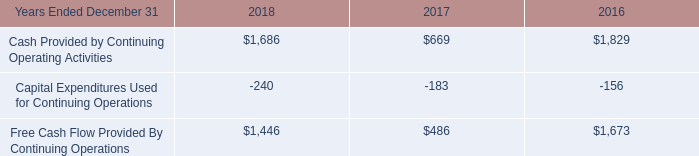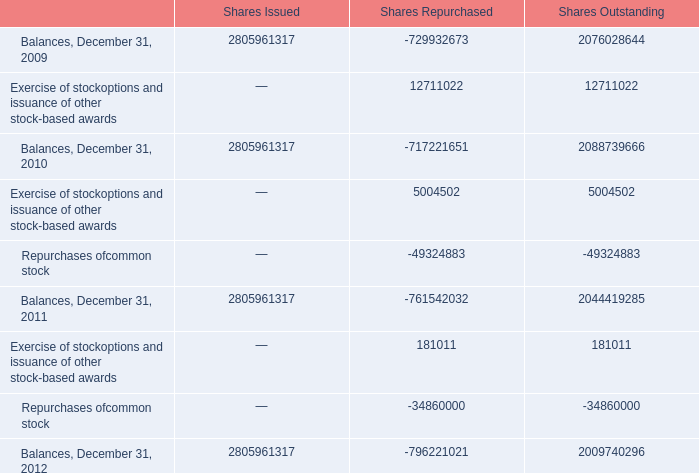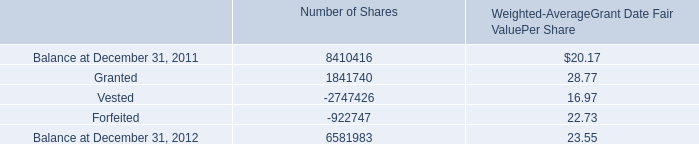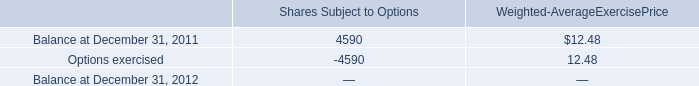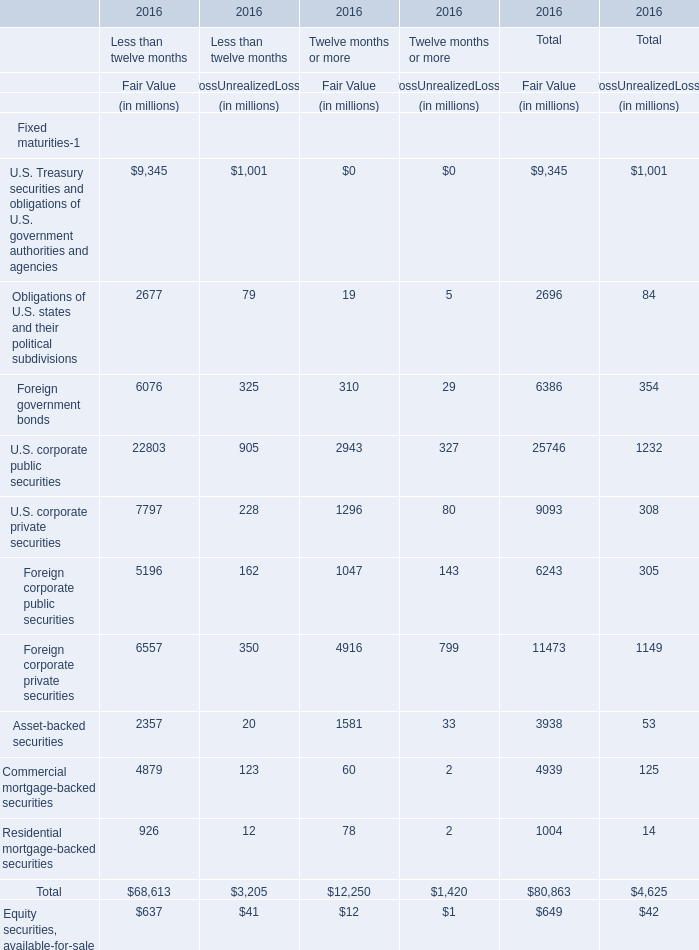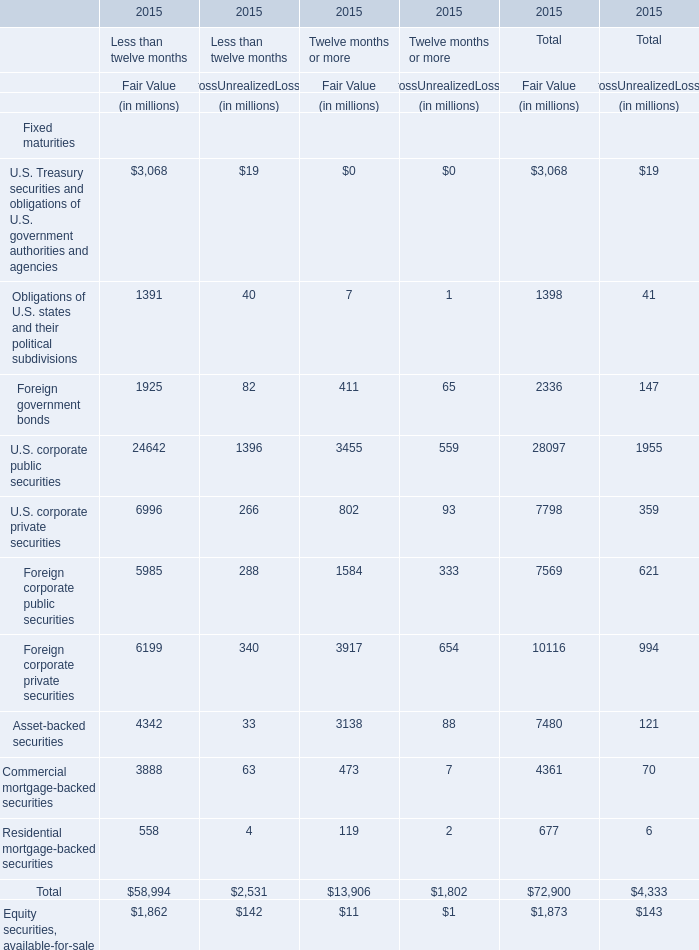What is the average amount of Free Cash Flow Provided By Continuing Operations of 2016, and Balance at December 31, 2011 of Shares Subject to Options ? 
Computations: ((1673.0 + 4590.0) / 2)
Answer: 3131.5. 